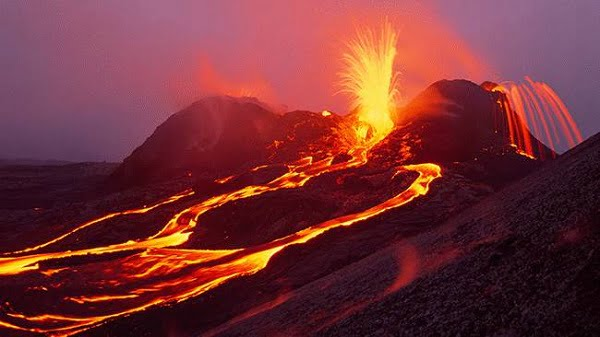Can you elaborate on the elements of the picture provided? The image vividly captures an ongoing volcanic eruption at the Hawaii Volcanoes National Park. Bright, molten lava flows spectacularly from multiple fissures on the mountain's slope, lighting the scene with an intense orange glow against the twilight sky. The sky, tinged with shades of dark gray, adds a dramatic backdrop that highlights the fiery nature of the eruption. This desolate landscape, devoid of vegetation, underscores the harsh conditions and the transformative power of volcanic activity. The composition of the image, taken from a safe distance, allows viewers to appreciate the scale of the eruption and contemplate the natural processes that shape such landscapes. 